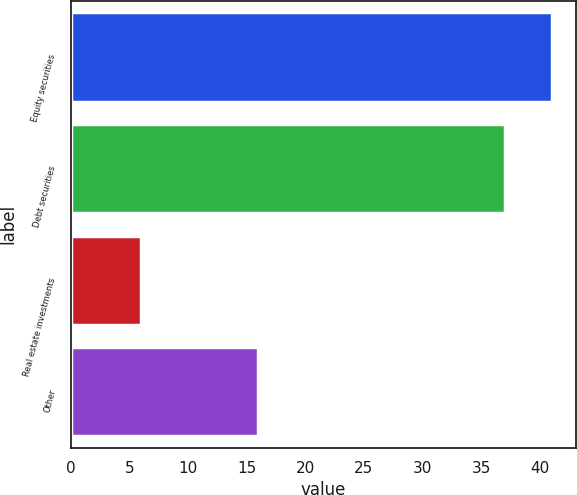Convert chart to OTSL. <chart><loc_0><loc_0><loc_500><loc_500><bar_chart><fcel>Equity securities<fcel>Debt securities<fcel>Real estate investments<fcel>Other<nl><fcel>41<fcel>37<fcel>6<fcel>16<nl></chart> 